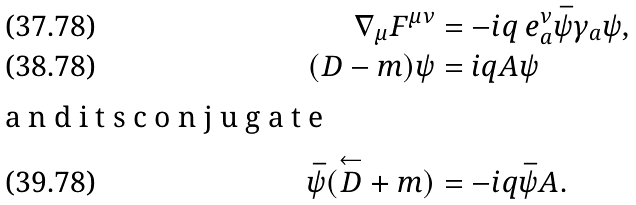<formula> <loc_0><loc_0><loc_500><loc_500>\nabla _ { \mu } F ^ { \mu \nu } & = - i q \ e ^ { \nu } _ { a } \bar { \psi } \gamma _ { a } \psi , \\ ( \sl D - m ) \psi & = i q \sl A \psi \\ \intertext { a n d i t s c o n j u g a t e } \bar { \psi } ( \overset { \leftarrow } { \sl D } + m ) & = - i q \bar { \psi } \sl A .</formula> 